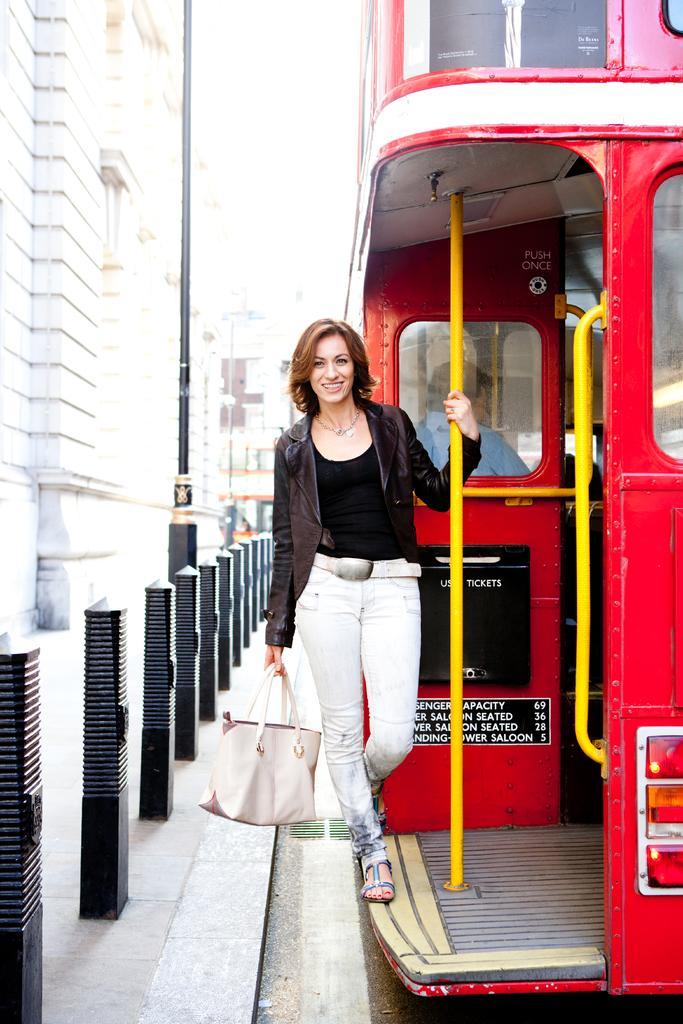How would you summarize this image in a sentence or two? In this image I see a woman who is smiling and standing on the vehicle and she is also carrying a handbag. In the background I can see few rods, a pole and the building. 